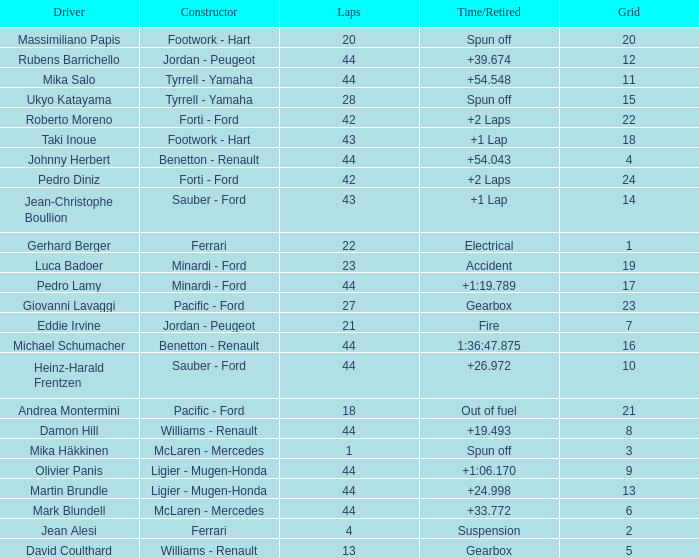What is the high lap total for cards with a grid larger than 21, and a Time/Retired of +2 laps? 42.0. 